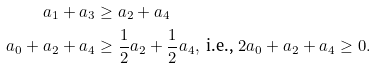<formula> <loc_0><loc_0><loc_500><loc_500>a _ { 1 } + a _ { 3 } & \geq a _ { 2 } + a _ { 4 } \\ a _ { 0 } + a _ { 2 } + a _ { 4 } & \geq { \frac { 1 } { 2 } } a _ { 2 } + \frac { 1 } { 2 } a _ { 4 } , \ \text {i.e.,} \ 2 a _ { 0 } + a _ { 2 } + a _ { 4 } \geq 0 .</formula> 